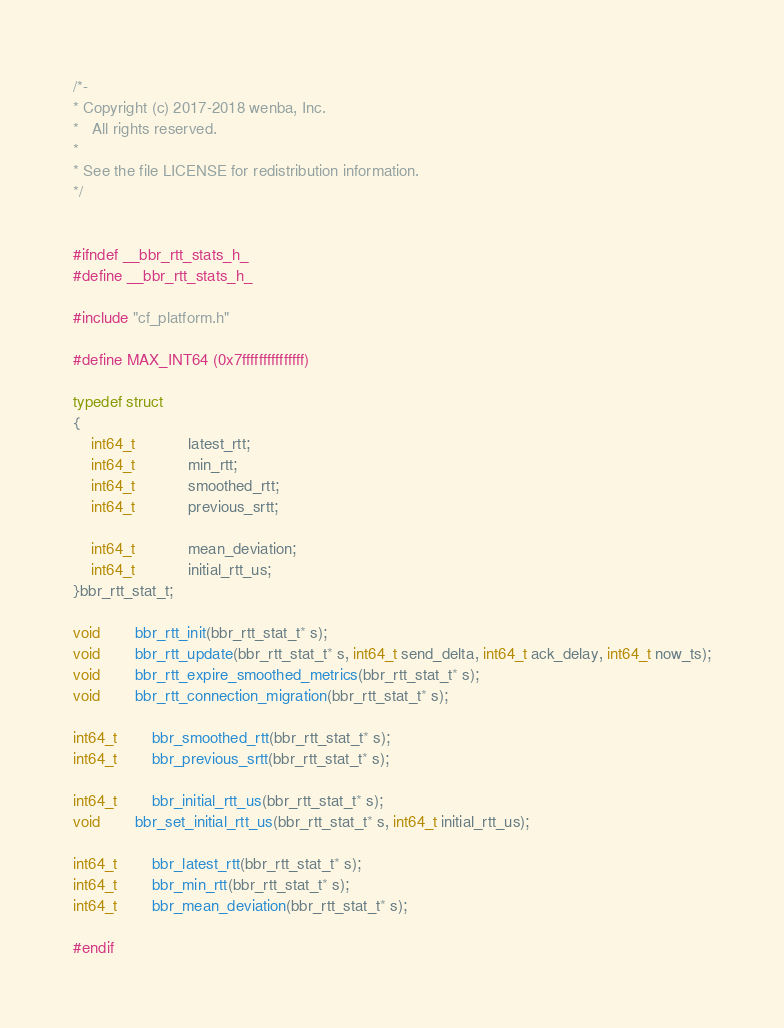<code> <loc_0><loc_0><loc_500><loc_500><_C_>/*-
* Copyright (c) 2017-2018 wenba, Inc.
*	All rights reserved.
*
* See the file LICENSE for redistribution information.
*/


#ifndef __bbr_rtt_stats_h_
#define __bbr_rtt_stats_h_

#include "cf_platform.h"

#define MAX_INT64 (0x7fffffffffffffff)

typedef struct
{
	int64_t			latest_rtt;
	int64_t			min_rtt;
	int64_t			smoothed_rtt;
	int64_t			previous_srtt;

	int64_t			mean_deviation;
	int64_t			initial_rtt_us;
}bbr_rtt_stat_t;

void		bbr_rtt_init(bbr_rtt_stat_t* s);
void		bbr_rtt_update(bbr_rtt_stat_t* s, int64_t send_delta, int64_t ack_delay, int64_t now_ts);
void		bbr_rtt_expire_smoothed_metrics(bbr_rtt_stat_t* s);
void		bbr_rtt_connection_migration(bbr_rtt_stat_t* s);

int64_t		bbr_smoothed_rtt(bbr_rtt_stat_t* s);
int64_t		bbr_previous_srtt(bbr_rtt_stat_t* s);

int64_t		bbr_initial_rtt_us(bbr_rtt_stat_t* s);
void		bbr_set_initial_rtt_us(bbr_rtt_stat_t* s, int64_t initial_rtt_us);

int64_t		bbr_latest_rtt(bbr_rtt_stat_t* s);
int64_t		bbr_min_rtt(bbr_rtt_stat_t* s);
int64_t		bbr_mean_deviation(bbr_rtt_stat_t* s);

#endif



</code> 